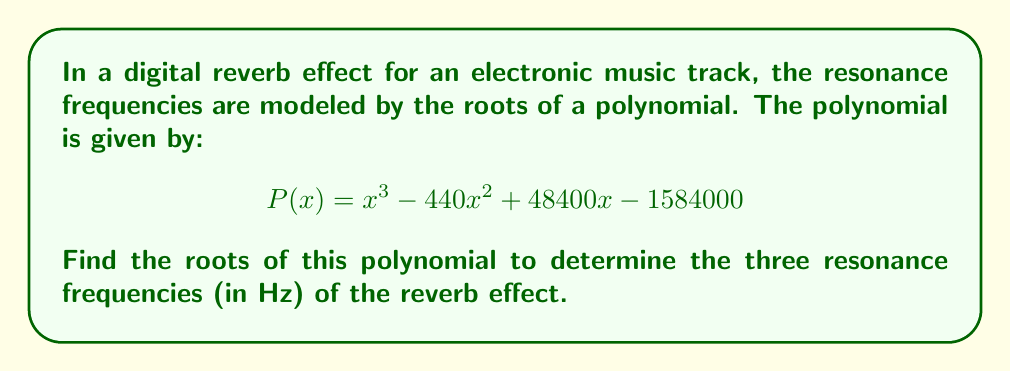What is the answer to this math problem? To find the roots of the polynomial, we need to factor it or use the cubic formula. In this case, we can use the rational root theorem to find one root, then factor out the remaining quadratic.

1) Using the rational root theorem, potential rational roots are factors of the constant term 1584000. Testing these, we find that 220 is a root.

2) Divide $P(x)$ by $(x - 220)$:

   $$ P(x) = (x - 220)(x^2 - 220x + 7200) $$

3) Now we need to solve the quadratic equation $x^2 - 220x + 7200 = 0$

4) Using the quadratic formula: $x = \frac{-b \pm \sqrt{b^2 - 4ac}}{2a}$

   Where $a=1$, $b=-220$, and $c=7200$

5) Substituting:

   $$ x = \frac{220 \pm \sqrt{220^2 - 4(1)(7200)}}{2(1)} $$
   $$ x = \frac{220 \pm \sqrt{48400 - 28800}}{2} $$
   $$ x = \frac{220 \pm \sqrt{19600}}{2} $$
   $$ x = \frac{220 \pm 140}{2} $$

6) This gives us two more roots:

   $$ x = \frac{220 + 140}{2} = 180 $$
   $$ x = \frac{220 - 140}{2} = 40 $$

Therefore, the three roots (and resonance frequencies) are 220 Hz, 180 Hz, and 40 Hz.
Answer: The resonance frequencies of the digital reverb effect are 220 Hz, 180 Hz, and 40 Hz. 